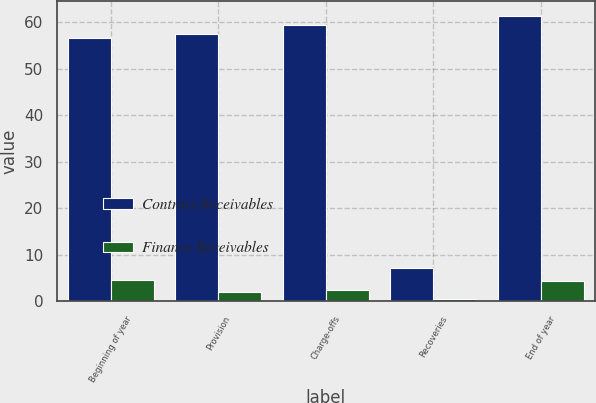Convert chart to OTSL. <chart><loc_0><loc_0><loc_500><loc_500><stacked_bar_chart><ecel><fcel>Beginning of year<fcel>Provision<fcel>Charge-offs<fcel>Recoveries<fcel>End of year<nl><fcel>Contract Receivables<fcel>56.5<fcel>57.5<fcel>59.4<fcel>7.1<fcel>61.4<nl><fcel>Finance Receivables<fcel>4.6<fcel>2<fcel>2.5<fcel>0.4<fcel>4.3<nl></chart> 